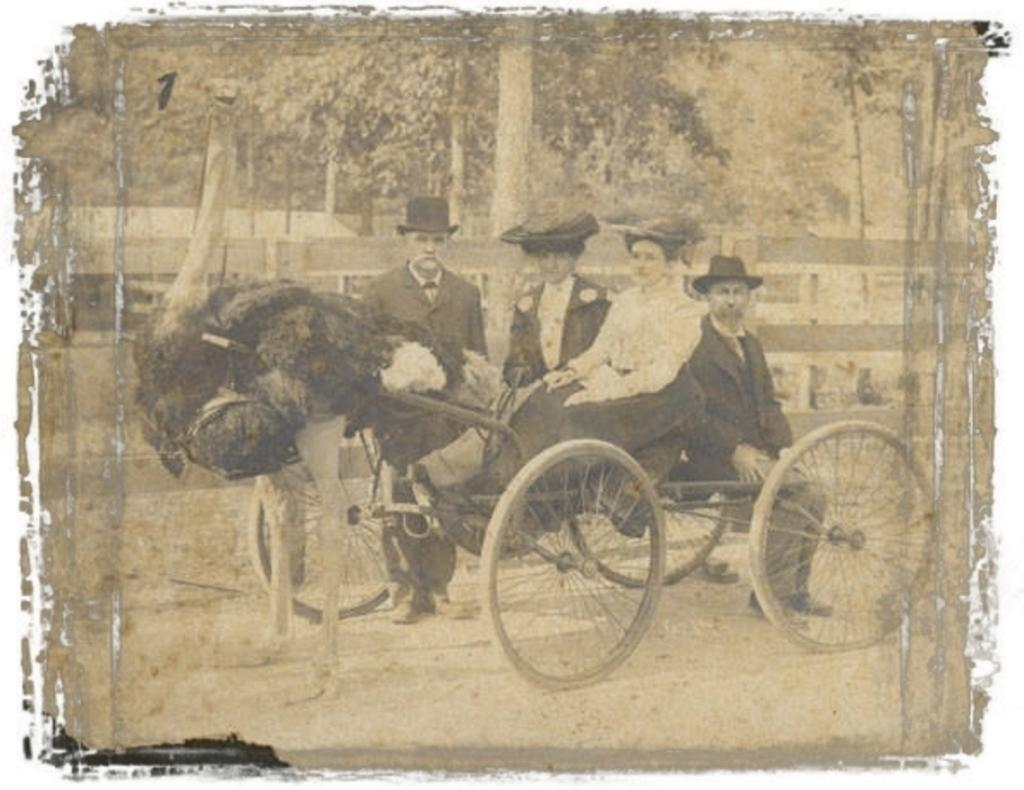What is happening in the foreground of the image? There are four persons sitting in a cart in the foreground of the image. What can be seen on the left side of the image? There is a bird on the left side of the image. What is visible in the background of the image? Trees are visible in the background of the image. How does the dust affect the digestion of the persons sitting in the cart in the image? There is no mention of dust in the image, and therefore its effect on the digestion of the persons sitting in the cart cannot be determined. 